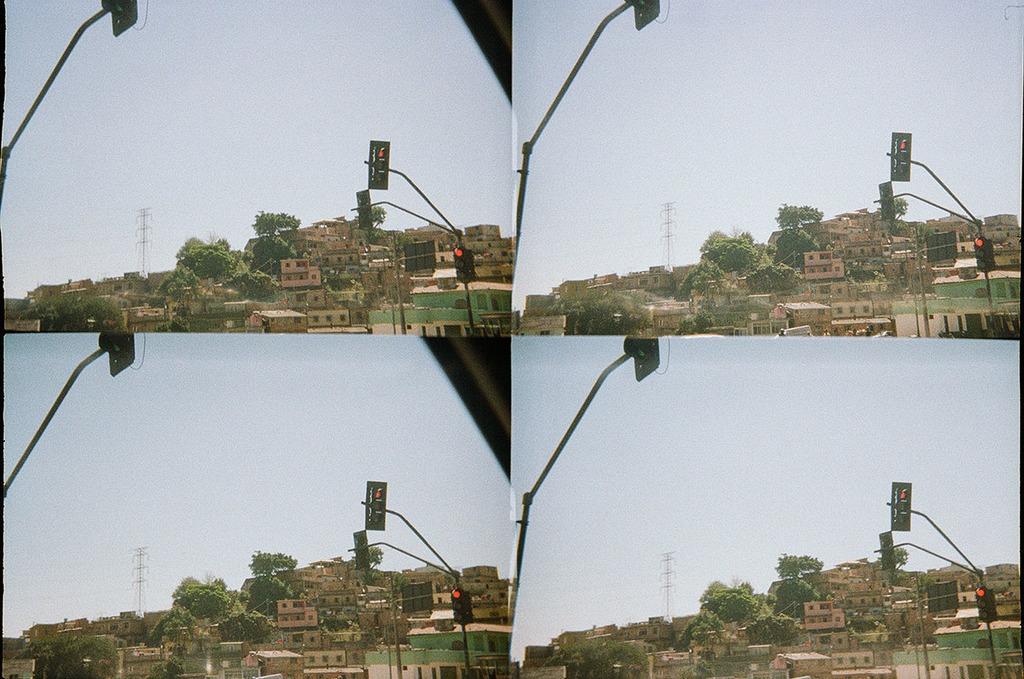How would you summarize this image in a sentence or two? In this image we can see four pictures where we can see traffic signal poles, boards, buildings, trees, tower and the sky in the background. 